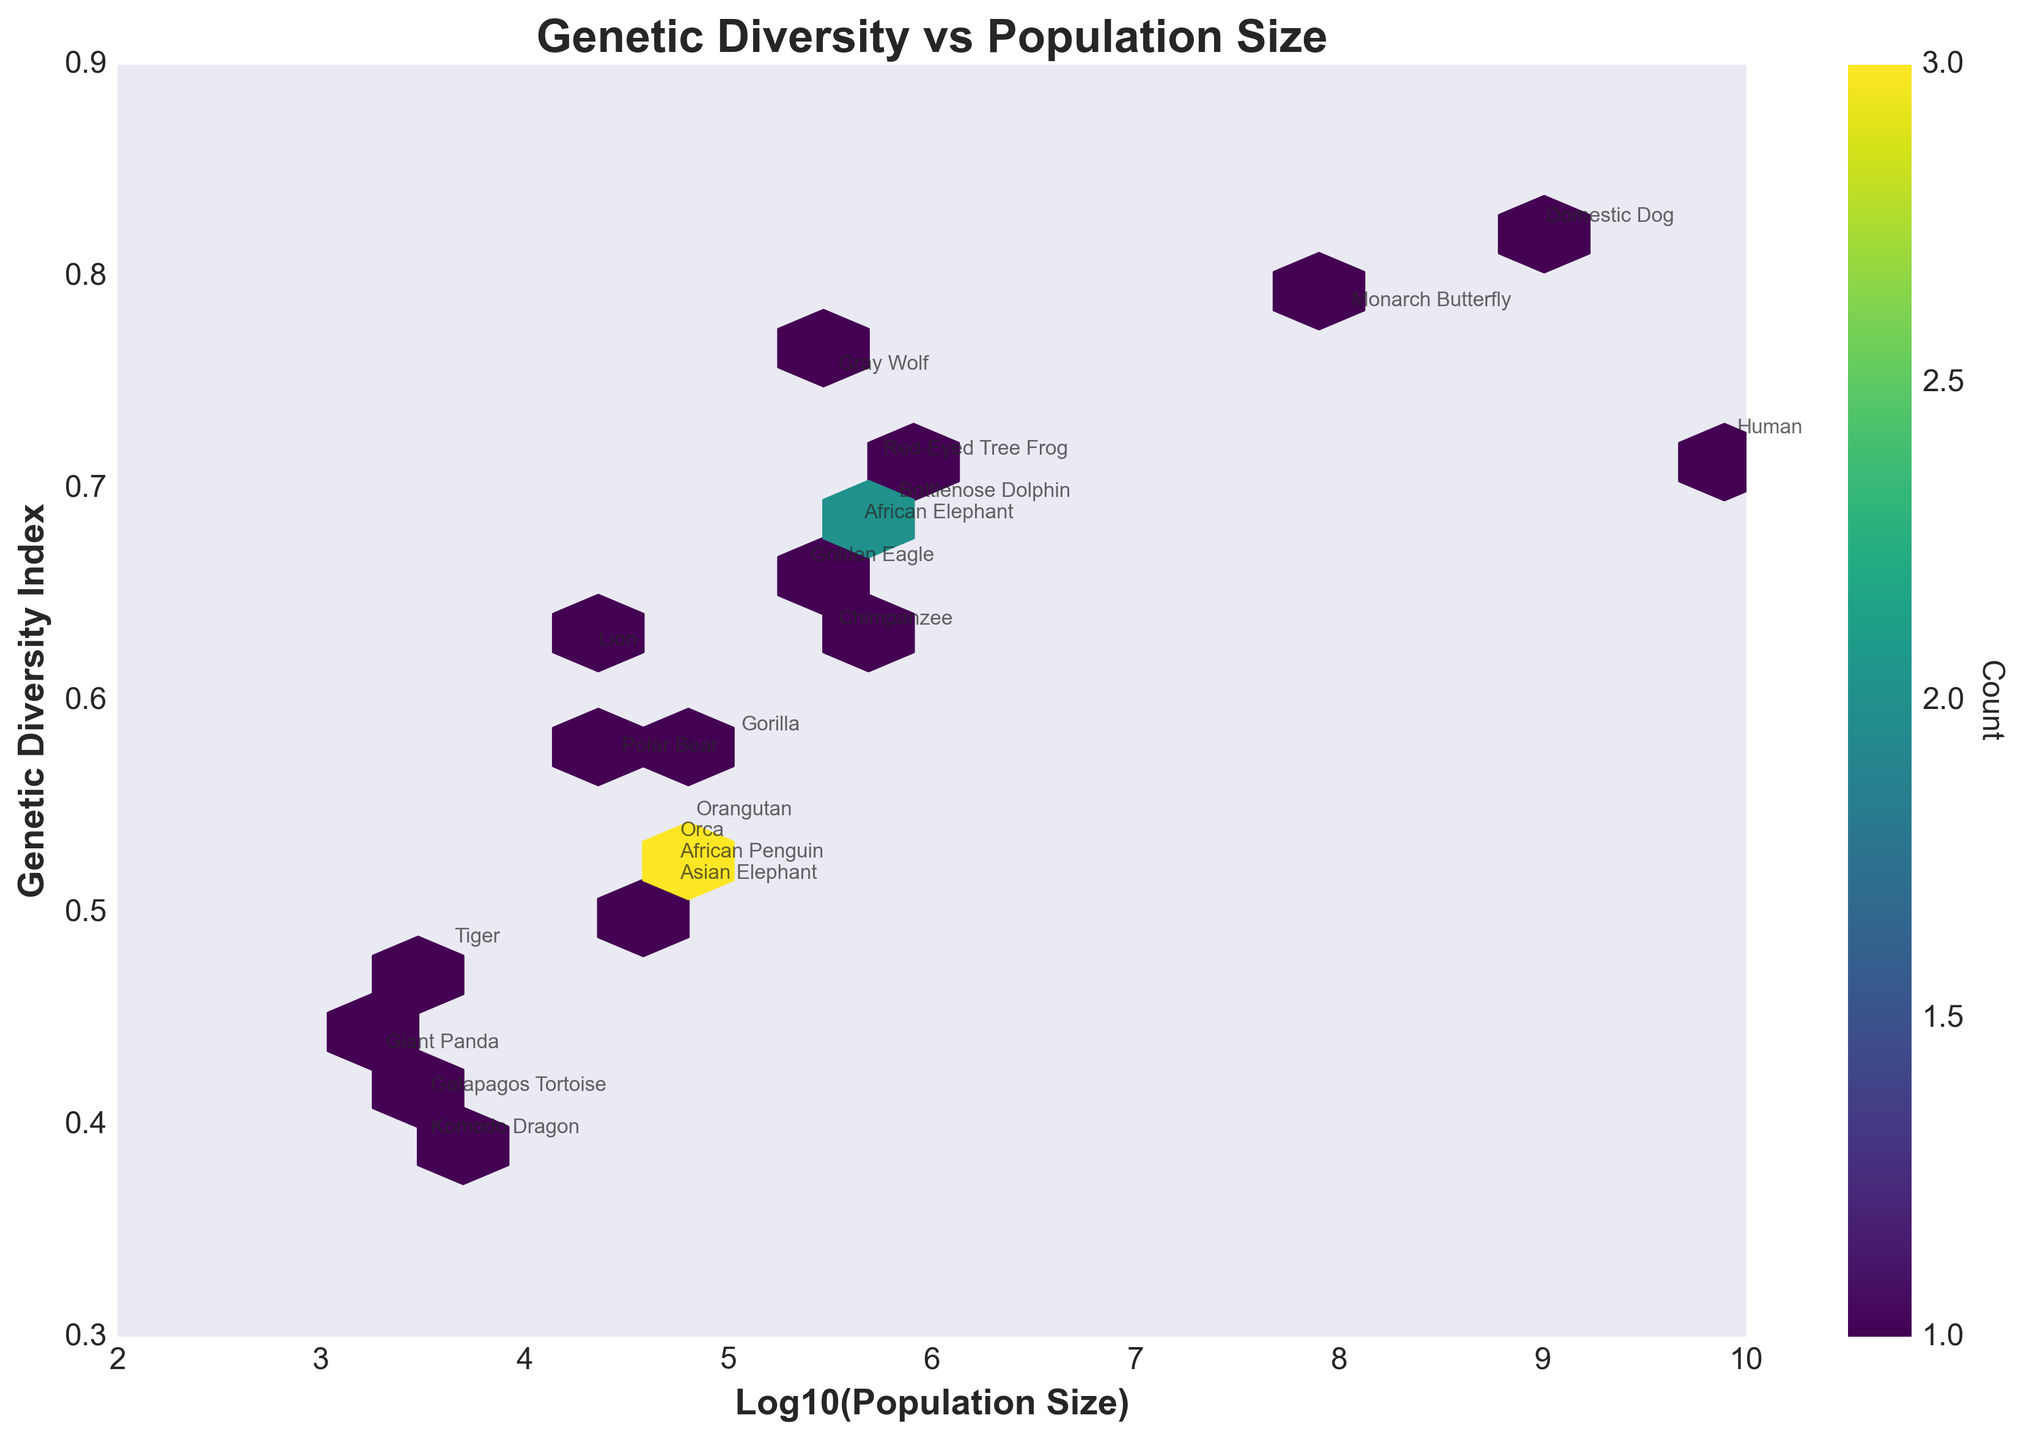what is the title of the plot? The title is located at the top center of the plot, often in larger and bold font. It provides a quick summary of what the plot depicts.
Answer: Genetic Diversity vs Population Size which species has the highest genetic diversity index? We look for the species with the highest value on the Y-axis, which represents the Genetic Diversity Index.
Answer: Domestic Dog how many species have a genetic diversity index lower than 0.5? We count the species whose data points fall below the 0.5 mark on the Y-axis.
Answer: Four (Komodo Dragon, Galapagos Tortoise, Tiger, and Asian Elephant) what is the average genetic diversity index of species with a population size greater than 1,000,000? First, identify species with a Log10(Population Size) greater than 6 (since Log10(1,000,000) = 6). These species are Human, Domestic Dog, Bottlenose Dolphin, and Monarch Butterfly. Then, calculate the average Genetic Diversity Index of these species. Average = (0.72 + 0.82 + 0.69 + 0.78) / 4 = 0.7525
Answer: 0.7525 which species is an outlier in terms of genetic diversity despite having a relatively high population size? Compare species with high population sizes by looking to the right-hand side of the plot and identifying which species have significantly different Genetic Diversity Index values. The Domestic Dog stands out with a Genetic Diversity Index greatly higher than others with large populations.
Answer: Domestic Dog how does the genetic diversity of giant pandas compare with that of orcas? Locate both species on the plot and compare their positions on the Y-axis representing Genetic Diversity Index.
Answer: Giant Pandas have lower genetic diversity (0.43) compared to Orcas (0.53) are there more species with a genetic diversity index above or below 0.6? Count the number of species with a Genetic Diversity Index above 0.6 and those with one below 0.6 to make the comparison. Above 0.6: 8 species, Below 0.6: 12 species.
Answer: Below 0.6 which species have a similar population size but different genetic diversity indices? Identify species located close to each other on the X-axis but at different levels on the Y-axis, indicating similar population sizes but varied Genetic Diversity Indices. Example: Chimpanzee and Gray Wolf.
Answer: Chimpanzee and Gray Wolf 